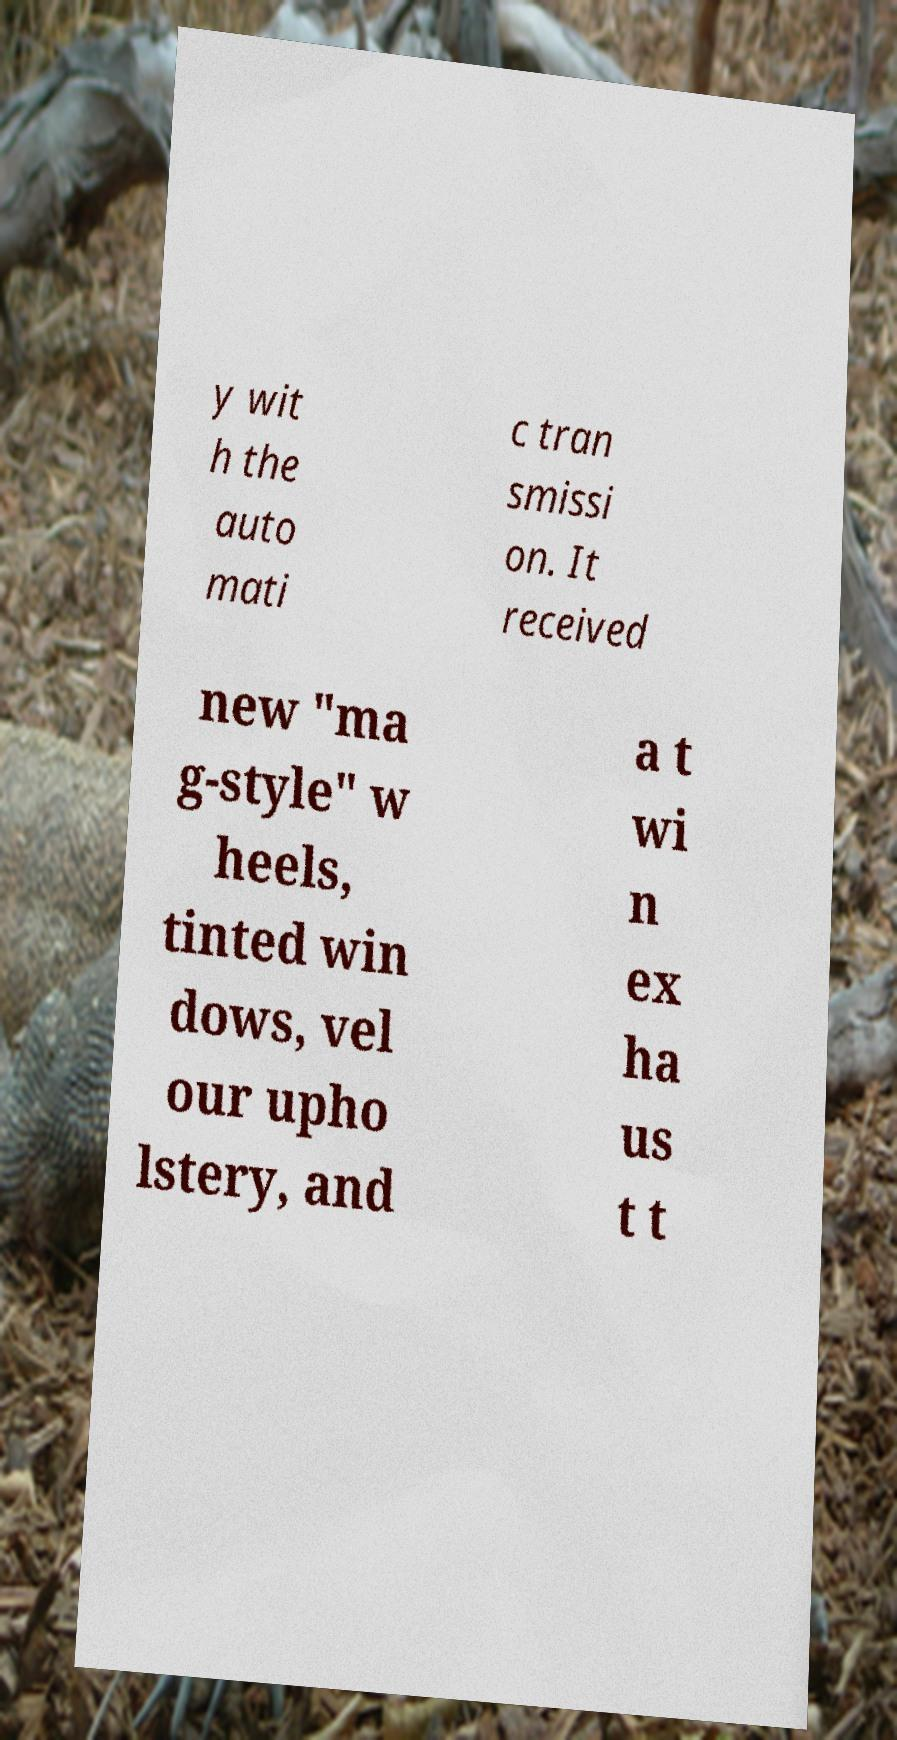Could you extract and type out the text from this image? y wit h the auto mati c tran smissi on. It received new "ma g-style" w heels, tinted win dows, vel our upho lstery, and a t wi n ex ha us t t 